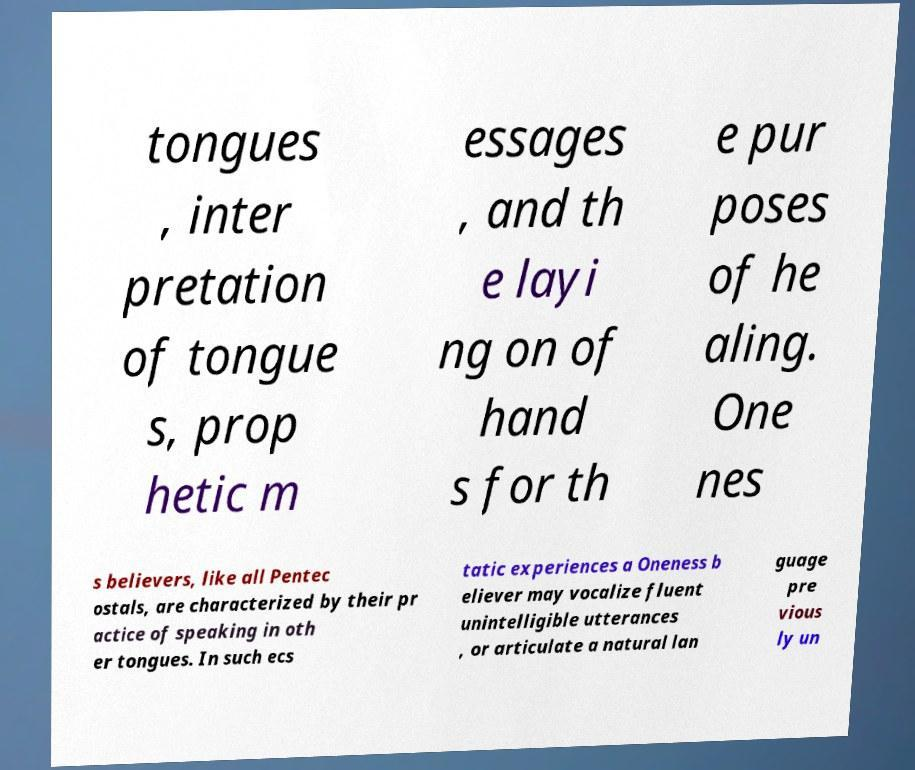For documentation purposes, I need the text within this image transcribed. Could you provide that? tongues , inter pretation of tongue s, prop hetic m essages , and th e layi ng on of hand s for th e pur poses of he aling. One nes s believers, like all Pentec ostals, are characterized by their pr actice of speaking in oth er tongues. In such ecs tatic experiences a Oneness b eliever may vocalize fluent unintelligible utterances , or articulate a natural lan guage pre vious ly un 